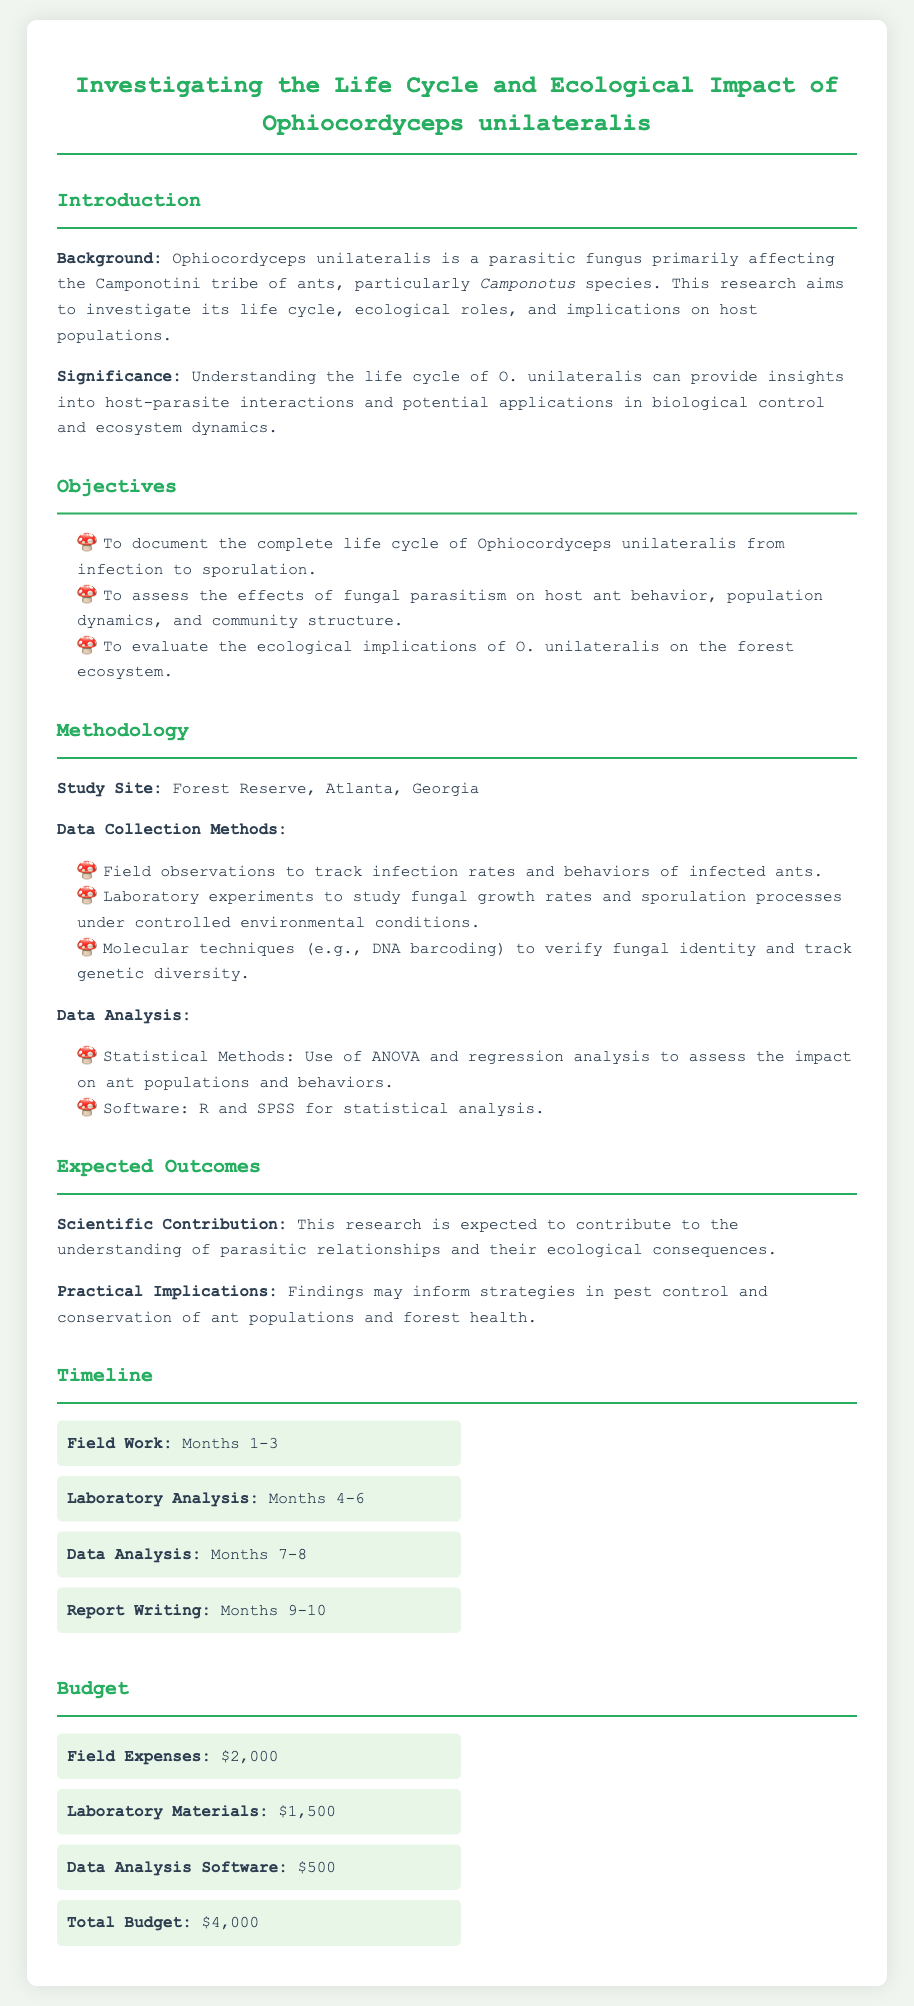What is the title of the research proposal? The title describes the focus of the research, which is the investigation of the life cycle and ecological impact of a specific parasitic fungus.
Answer: Investigating the Life Cycle and Ecological Impact of Ophiocordyceps unilateralis What species of ants does Ophiocordyceps unilateralis affect? The document states that the parasitic fungus primarily affects a specific tribe of ants.
Answer: Camponotini Where is the study site located? The study site is mentioned in the methodology section as the location for data collection.
Answer: Forest Reserve, Atlanta, Georgia What is the total budget for the research? The total budget is indicated in the budget section of the document.
Answer: $4,000 What statistical methods are mentioned for data analysis? The document provides specific statistical methods used for analyzing the research data.
Answer: ANOVA and regression analysis How many months are allocated for field work? The timeline section of the document specifies the duration for field work.
Answer: 3 months What are the expected practical implications of the research? The document mentions practical implications in relation to pest control and ecosystem health.
Answer: Pest control and conservation of ant populations and forest health What molecular technique will be used in the research? The methodology section describes a specific molecular technique for verifying fungal identity.
Answer: DNA barcoding 